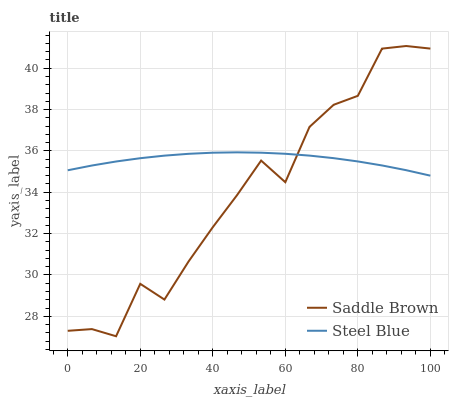Does Saddle Brown have the minimum area under the curve?
Answer yes or no. Yes. Does Steel Blue have the maximum area under the curve?
Answer yes or no. Yes. Does Steel Blue have the minimum area under the curve?
Answer yes or no. No. Is Steel Blue the smoothest?
Answer yes or no. Yes. Is Saddle Brown the roughest?
Answer yes or no. Yes. Is Steel Blue the roughest?
Answer yes or no. No. Does Saddle Brown have the lowest value?
Answer yes or no. Yes. Does Steel Blue have the lowest value?
Answer yes or no. No. Does Saddle Brown have the highest value?
Answer yes or no. Yes. Does Steel Blue have the highest value?
Answer yes or no. No. Does Steel Blue intersect Saddle Brown?
Answer yes or no. Yes. Is Steel Blue less than Saddle Brown?
Answer yes or no. No. Is Steel Blue greater than Saddle Brown?
Answer yes or no. No. 